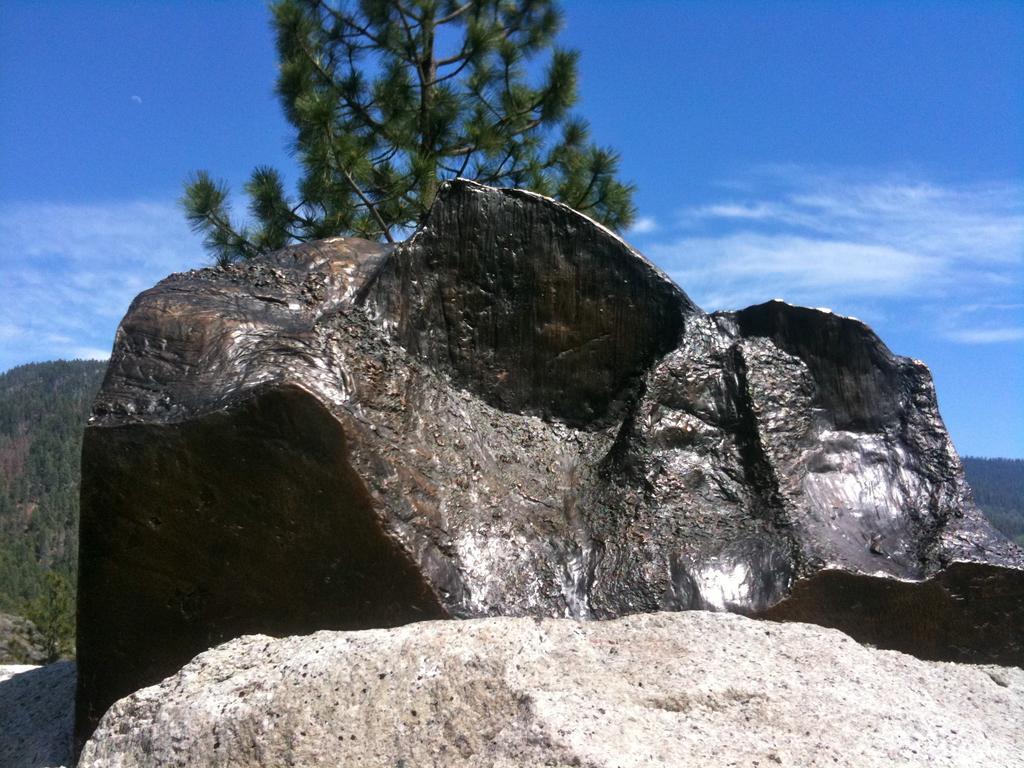In one or two sentences, can you explain what this image depicts? In this image I can see few stones and a tree in the front. In the background I can see number of trees, clouds and the sky. 